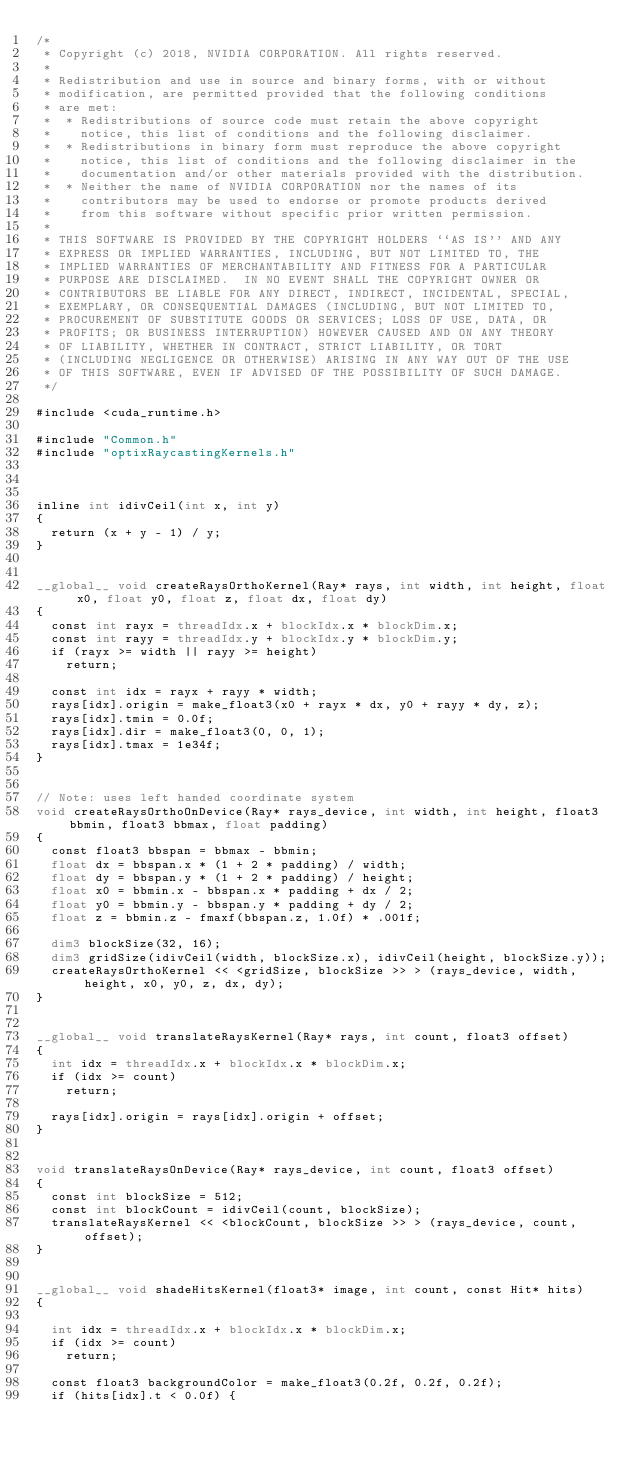Convert code to text. <code><loc_0><loc_0><loc_500><loc_500><_Cuda_>/*
 * Copyright (c) 2018, NVIDIA CORPORATION. All rights reserved.
 *
 * Redistribution and use in source and binary forms, with or without
 * modification, are permitted provided that the following conditions
 * are met:
 *  * Redistributions of source code must retain the above copyright
 *    notice, this list of conditions and the following disclaimer.
 *  * Redistributions in binary form must reproduce the above copyright
 *    notice, this list of conditions and the following disclaimer in the
 *    documentation and/or other materials provided with the distribution.
 *  * Neither the name of NVIDIA CORPORATION nor the names of its
 *    contributors may be used to endorse or promote products derived
 *    from this software without specific prior written permission.
 *
 * THIS SOFTWARE IS PROVIDED BY THE COPYRIGHT HOLDERS ``AS IS'' AND ANY
 * EXPRESS OR IMPLIED WARRANTIES, INCLUDING, BUT NOT LIMITED TO, THE
 * IMPLIED WARRANTIES OF MERCHANTABILITY AND FITNESS FOR A PARTICULAR
 * PURPOSE ARE DISCLAIMED.  IN NO EVENT SHALL THE COPYRIGHT OWNER OR
 * CONTRIBUTORS BE LIABLE FOR ANY DIRECT, INDIRECT, INCIDENTAL, SPECIAL,
 * EXEMPLARY, OR CONSEQUENTIAL DAMAGES (INCLUDING, BUT NOT LIMITED TO,
 * PROCUREMENT OF SUBSTITUTE GOODS OR SERVICES; LOSS OF USE, DATA, OR
 * PROFITS; OR BUSINESS INTERRUPTION) HOWEVER CAUSED AND ON ANY THEORY
 * OF LIABILITY, WHETHER IN CONTRACT, STRICT LIABILITY, OR TORT
 * (INCLUDING NEGLIGENCE OR OTHERWISE) ARISING IN ANY WAY OUT OF THE USE
 * OF THIS SOFTWARE, EVEN IF ADVISED OF THE POSSIBILITY OF SUCH DAMAGE.
 */

#include <cuda_runtime.h>

#include "Common.h"
#include "optixRaycastingKernels.h"



inline int idivCeil(int x, int y)
{
	return (x + y - 1) / y;
}


__global__ void createRaysOrthoKernel(Ray* rays, int width, int height, float x0, float y0, float z, float dx, float dy)
{
	const int rayx = threadIdx.x + blockIdx.x * blockDim.x;
	const int rayy = threadIdx.y + blockIdx.y * blockDim.y;
	if (rayx >= width || rayy >= height)
		return;

	const int idx = rayx + rayy * width;
	rays[idx].origin = make_float3(x0 + rayx * dx, y0 + rayy * dy, z);
	rays[idx].tmin = 0.0f;
	rays[idx].dir = make_float3(0, 0, 1);
	rays[idx].tmax = 1e34f;
}


// Note: uses left handed coordinate system
void createRaysOrthoOnDevice(Ray* rays_device, int width, int height, float3 bbmin, float3 bbmax, float padding)
{
	const float3 bbspan = bbmax - bbmin;
	float dx = bbspan.x * (1 + 2 * padding) / width;
	float dy = bbspan.y * (1 + 2 * padding) / height;
	float x0 = bbmin.x - bbspan.x * padding + dx / 2;
	float y0 = bbmin.y - bbspan.y * padding + dy / 2;
	float z = bbmin.z - fmaxf(bbspan.z, 1.0f) * .001f;

	dim3 blockSize(32, 16);
	dim3 gridSize(idivCeil(width, blockSize.x), idivCeil(height, blockSize.y));
	createRaysOrthoKernel << <gridSize, blockSize >> > (rays_device, width, height, x0, y0, z, dx, dy);
}


__global__ void translateRaysKernel(Ray* rays, int count, float3 offset)
{
	int idx = threadIdx.x + blockIdx.x * blockDim.x;
	if (idx >= count)
		return;

	rays[idx].origin = rays[idx].origin + offset;
}


void translateRaysOnDevice(Ray* rays_device, int count, float3 offset)
{
	const int blockSize = 512;
	const int blockCount = idivCeil(count, blockSize);
	translateRaysKernel << <blockCount, blockSize >> > (rays_device, count, offset);
}


__global__ void shadeHitsKernel(float3* image, int count, const Hit* hits)
{

	int idx = threadIdx.x + blockIdx.x * blockDim.x;
	if (idx >= count)
		return;

	const float3 backgroundColor = make_float3(0.2f, 0.2f, 0.2f);
	if (hits[idx].t < 0.0f) {</code> 